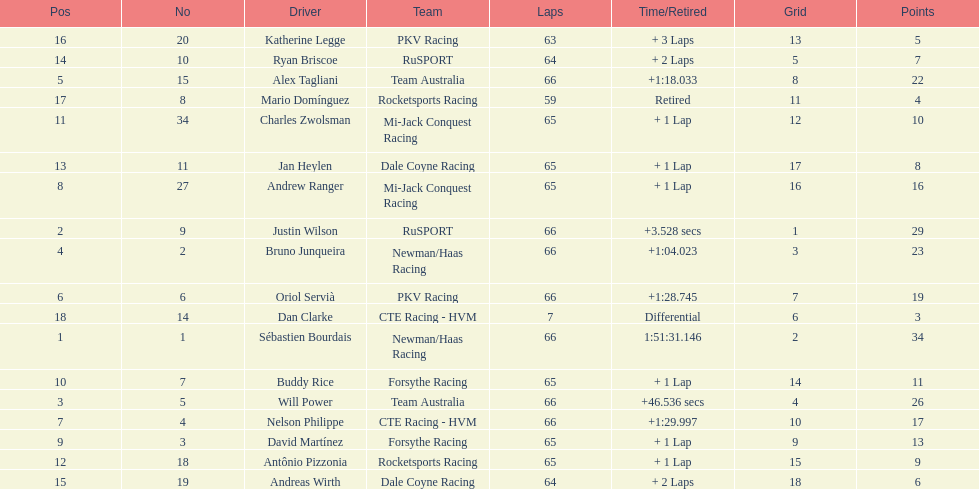At the 2006 gran premio telmex, who finished last? Dan Clarke. 